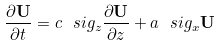Convert formula to latex. <formula><loc_0><loc_0><loc_500><loc_500>\frac { \partial \mathbf U } { \partial t } = c \ s i g _ { z } \frac { \partial \mathbf U } { \partial z } + a \ s i g _ { x } \mathbf U</formula> 